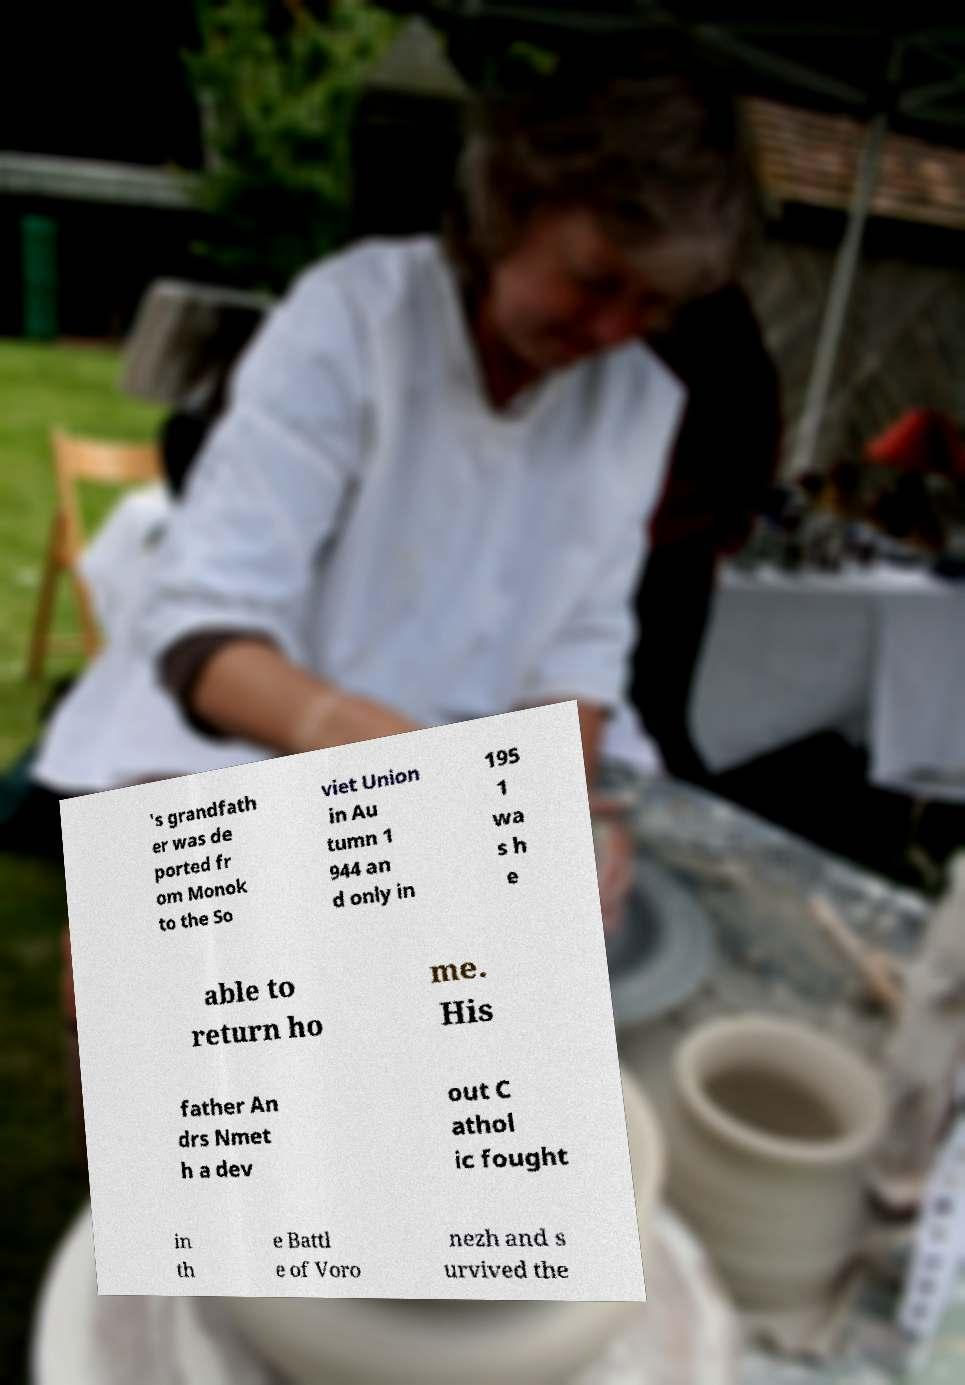I need the written content from this picture converted into text. Can you do that? 's grandfath er was de ported fr om Monok to the So viet Union in Au tumn 1 944 an d only in 195 1 wa s h e able to return ho me. His father An drs Nmet h a dev out C athol ic fought in th e Battl e of Voro nezh and s urvived the 